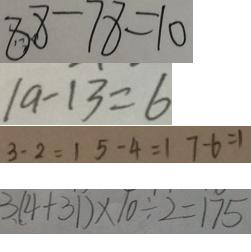Convert formula to latex. <formula><loc_0><loc_0><loc_500><loc_500>8 8 - 7 8 = 1 0 
 1 9 - 1 3 = 6 
 3 - 2 = 1 5 - 4 = 1 7 - 6 = 1 
 3 . ( 4 + 3 1 ) \times 1 0 \div 2 = 1 7 5</formula> 